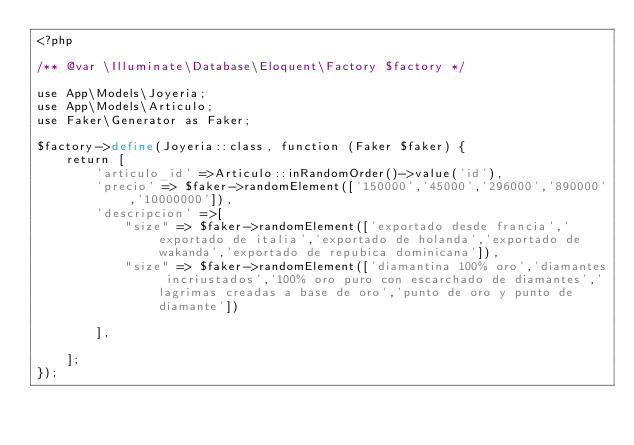<code> <loc_0><loc_0><loc_500><loc_500><_PHP_><?php

/** @var \Illuminate\Database\Eloquent\Factory $factory */

use App\Models\Joyeria;
use App\Models\Articulo;
use Faker\Generator as Faker;

$factory->define(Joyeria::class, function (Faker $faker) {
    return [
        'articulo_id' =>Articulo::inRandomOrder()->value('id'),
        'precio' => $faker->randomElement(['150000','45000','296000','890000','10000000']),
        'descripcion' =>[
            "size" => $faker->randomElement(['exportado desde francia','exportado de italia','exportado de holanda','exportado de wakanda','exportado de repubica dominicana']),
            "size" => $faker->randomElement(['diamantina 100% oro','diamantes incriustados','100% oro puro con escarchado de diamantes','lagrimas creadas a base de oro','punto de oro y punto de diamante'])
             
        ],

    ];
});
</code> 